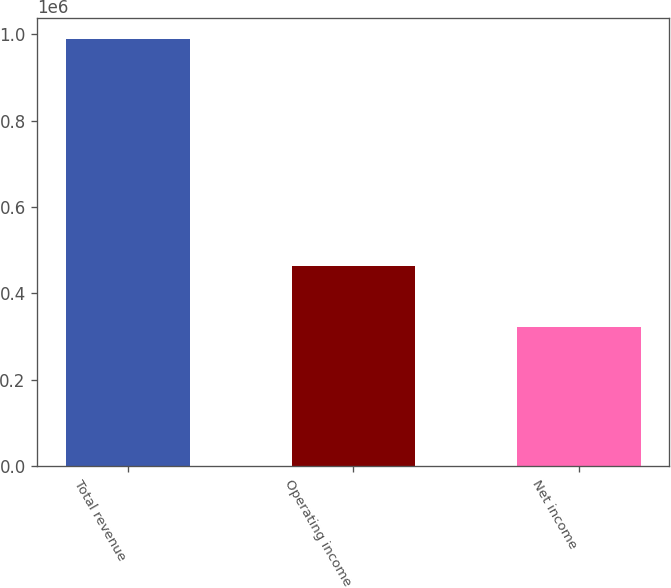<chart> <loc_0><loc_0><loc_500><loc_500><bar_chart><fcel>Total revenue<fcel>Operating income<fcel>Net income<nl><fcel>988568<fcel>464356<fcel>322922<nl></chart> 